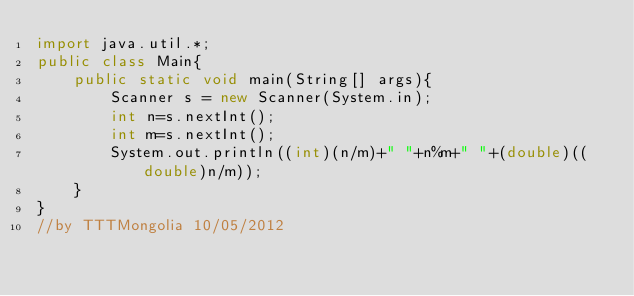<code> <loc_0><loc_0><loc_500><loc_500><_Java_>import java.util.*;
public class Main{
    public static void main(String[] args){
        Scanner s = new Scanner(System.in);
        int n=s.nextInt();
        int m=s.nextInt();
        System.out.println((int)(n/m)+" "+n%m+" "+(double)((double)n/m));
    }
}
//by TTTMongolia 10/05/2012</code> 